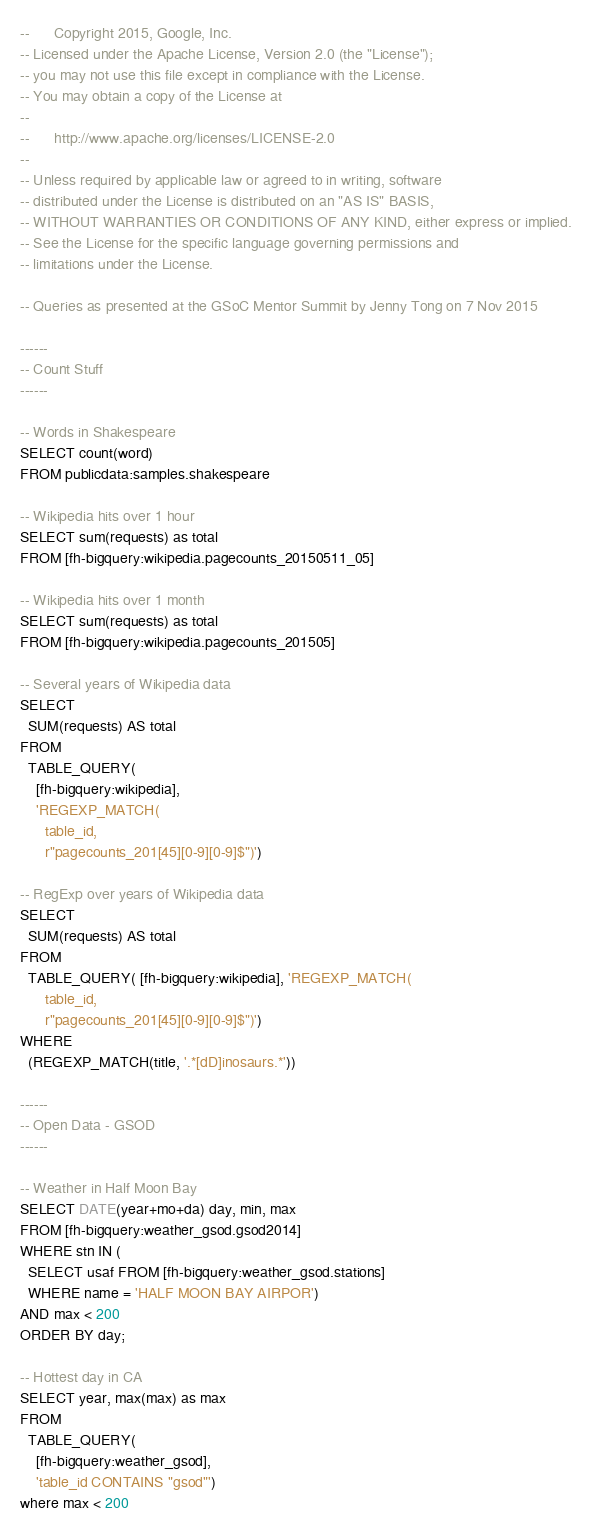<code> <loc_0><loc_0><loc_500><loc_500><_SQL_>--      Copyright 2015, Google, Inc.
-- Licensed under the Apache License, Version 2.0 (the "License");
-- you may not use this file except in compliance with the License.
-- You may obtain a copy of the License at
--
--      http://www.apache.org/licenses/LICENSE-2.0
--
-- Unless required by applicable law or agreed to in writing, software
-- distributed under the License is distributed on an "AS IS" BASIS,
-- WITHOUT WARRANTIES OR CONDITIONS OF ANY KIND, either express or implied.
-- See the License for the specific language governing permissions and
-- limitations under the License.

-- Queries as presented at the GSoC Mentor Summit by Jenny Tong on 7 Nov 2015

------
-- Count Stuff
------

-- Words in Shakespeare
SELECT count(word)
FROM publicdata:samples.shakespeare

-- Wikipedia hits over 1 hour
SELECT sum(requests) as total
FROM [fh-bigquery:wikipedia.pagecounts_20150511_05]

-- Wikipedia hits over 1 month
SELECT sum(requests) as total
FROM [fh-bigquery:wikipedia.pagecounts_201505]

-- Several years of Wikipedia data
SELECT
  SUM(requests) AS total
FROM
  TABLE_QUERY(
    [fh-bigquery:wikipedia], 
    'REGEXP_MATCH(
      table_id, 
      r"pagecounts_201[45][0-9][0-9]$")')

-- RegExp over years of Wikipedia data
SELECT
  SUM(requests) AS total
FROM
  TABLE_QUERY( [fh-bigquery:wikipedia], 'REGEXP_MATCH(
      table_id, 
      r"pagecounts_201[45][0-9][0-9]$")')
WHERE
  (REGEXP_MATCH(title, '.*[dD]inosaurs.*'))

------
-- Open Data - GSOD
------

-- Weather in Half Moon Bay
SELECT DATE(year+mo+da) day, min, max
FROM [fh-bigquery:weather_gsod.gsod2014] 
WHERE stn IN (
  SELECT usaf FROM [fh-bigquery:weather_gsod.stations] 
  WHERE name = 'HALF MOON BAY AIRPOR')
AND max < 200
ORDER BY day;

-- Hottest day in CA
SELECT year, max(max) as max
FROM
  TABLE_QUERY(
    [fh-bigquery:weather_gsod], 
    'table_id CONTAINS "gsod"')
where max < 200    </code> 